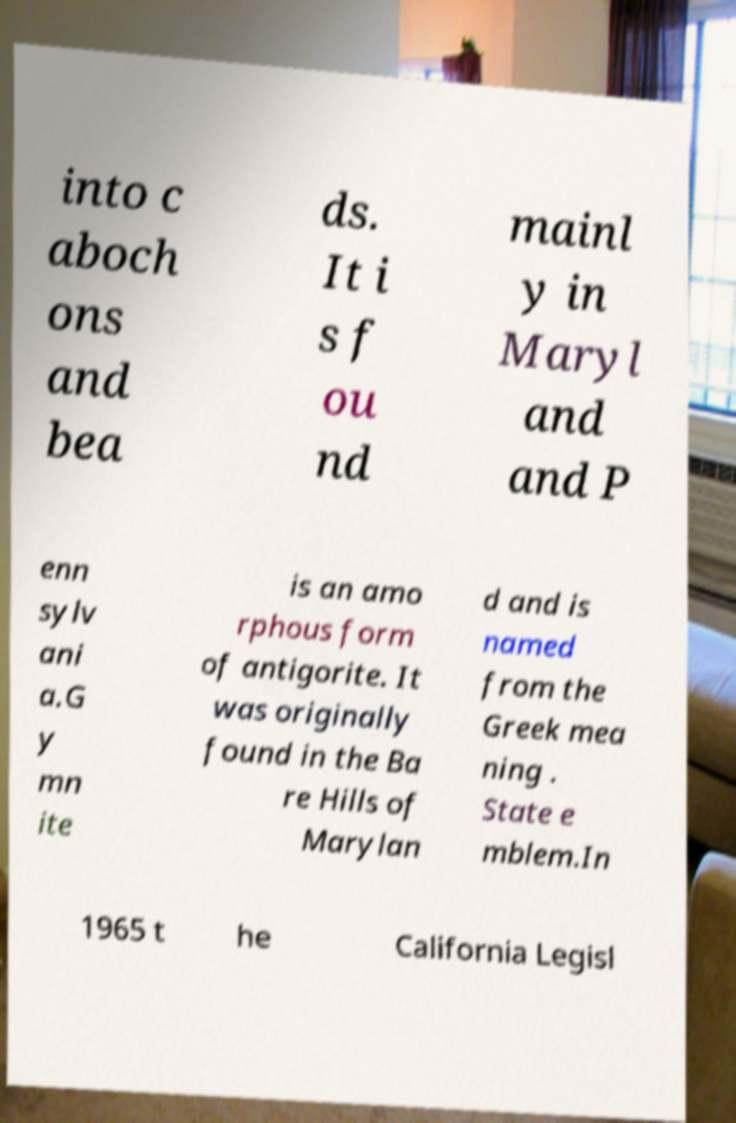Please identify and transcribe the text found in this image. into c aboch ons and bea ds. It i s f ou nd mainl y in Maryl and and P enn sylv ani a.G y mn ite is an amo rphous form of antigorite. It was originally found in the Ba re Hills of Marylan d and is named from the Greek mea ning . State e mblem.In 1965 t he California Legisl 